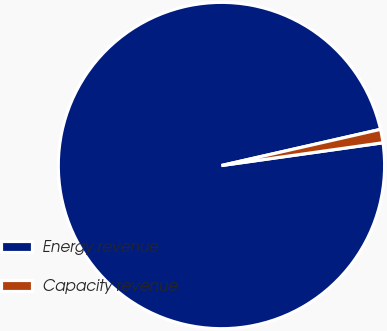Convert chart to OTSL. <chart><loc_0><loc_0><loc_500><loc_500><pie_chart><fcel>Energy revenue<fcel>Capacity revenue<nl><fcel>98.67%<fcel>1.33%<nl></chart> 